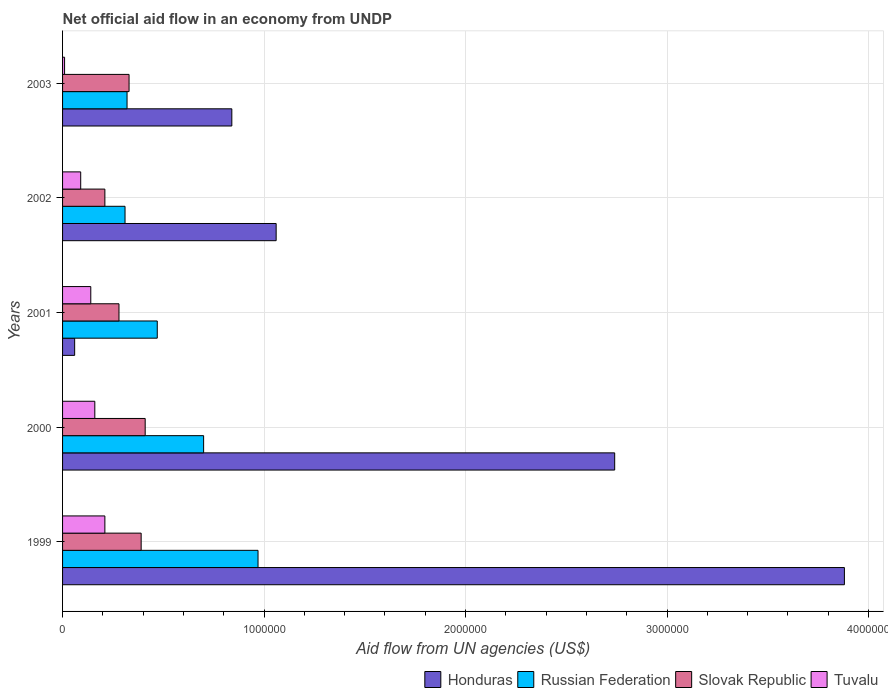How many different coloured bars are there?
Make the answer very short. 4. Are the number of bars per tick equal to the number of legend labels?
Provide a short and direct response. Yes. How many bars are there on the 5th tick from the top?
Ensure brevity in your answer.  4. What is the label of the 2nd group of bars from the top?
Your answer should be compact. 2002. In how many cases, is the number of bars for a given year not equal to the number of legend labels?
Your answer should be very brief. 0. Across all years, what is the maximum net official aid flow in Honduras?
Your answer should be very brief. 3.88e+06. Across all years, what is the minimum net official aid flow in Honduras?
Offer a very short reply. 6.00e+04. What is the total net official aid flow in Honduras in the graph?
Offer a terse response. 8.58e+06. What is the difference between the net official aid flow in Slovak Republic in 2001 and the net official aid flow in Honduras in 2002?
Your response must be concise. -7.80e+05. What is the average net official aid flow in Tuvalu per year?
Offer a terse response. 1.22e+05. In how many years, is the net official aid flow in Russian Federation greater than 2200000 US$?
Ensure brevity in your answer.  0. What is the ratio of the net official aid flow in Tuvalu in 1999 to that in 2002?
Your answer should be compact. 2.33. Is the net official aid flow in Honduras in 2002 less than that in 2003?
Your answer should be very brief. No. What does the 3rd bar from the top in 2000 represents?
Offer a terse response. Russian Federation. What does the 4th bar from the bottom in 1999 represents?
Ensure brevity in your answer.  Tuvalu. Is it the case that in every year, the sum of the net official aid flow in Russian Federation and net official aid flow in Slovak Republic is greater than the net official aid flow in Honduras?
Provide a short and direct response. No. How many bars are there?
Provide a succinct answer. 20. Are all the bars in the graph horizontal?
Provide a short and direct response. Yes. How many years are there in the graph?
Your answer should be compact. 5. Are the values on the major ticks of X-axis written in scientific E-notation?
Make the answer very short. No. Does the graph contain any zero values?
Ensure brevity in your answer.  No. Does the graph contain grids?
Your response must be concise. Yes. How are the legend labels stacked?
Keep it short and to the point. Horizontal. What is the title of the graph?
Your answer should be very brief. Net official aid flow in an economy from UNDP. Does "Portugal" appear as one of the legend labels in the graph?
Make the answer very short. No. What is the label or title of the X-axis?
Your answer should be compact. Aid flow from UN agencies (US$). What is the Aid flow from UN agencies (US$) of Honduras in 1999?
Make the answer very short. 3.88e+06. What is the Aid flow from UN agencies (US$) of Russian Federation in 1999?
Offer a very short reply. 9.70e+05. What is the Aid flow from UN agencies (US$) of Honduras in 2000?
Your response must be concise. 2.74e+06. What is the Aid flow from UN agencies (US$) of Tuvalu in 2000?
Make the answer very short. 1.60e+05. What is the Aid flow from UN agencies (US$) of Russian Federation in 2001?
Your answer should be compact. 4.70e+05. What is the Aid flow from UN agencies (US$) in Tuvalu in 2001?
Your answer should be compact. 1.40e+05. What is the Aid flow from UN agencies (US$) of Honduras in 2002?
Ensure brevity in your answer.  1.06e+06. What is the Aid flow from UN agencies (US$) of Russian Federation in 2002?
Your answer should be compact. 3.10e+05. What is the Aid flow from UN agencies (US$) of Slovak Republic in 2002?
Make the answer very short. 2.10e+05. What is the Aid flow from UN agencies (US$) of Honduras in 2003?
Your answer should be compact. 8.40e+05. What is the Aid flow from UN agencies (US$) of Tuvalu in 2003?
Offer a very short reply. 10000. Across all years, what is the maximum Aid flow from UN agencies (US$) of Honduras?
Your answer should be very brief. 3.88e+06. Across all years, what is the maximum Aid flow from UN agencies (US$) of Russian Federation?
Your answer should be compact. 9.70e+05. Across all years, what is the maximum Aid flow from UN agencies (US$) of Tuvalu?
Provide a succinct answer. 2.10e+05. Across all years, what is the minimum Aid flow from UN agencies (US$) in Honduras?
Your answer should be very brief. 6.00e+04. Across all years, what is the minimum Aid flow from UN agencies (US$) in Slovak Republic?
Give a very brief answer. 2.10e+05. Across all years, what is the minimum Aid flow from UN agencies (US$) of Tuvalu?
Make the answer very short. 10000. What is the total Aid flow from UN agencies (US$) of Honduras in the graph?
Offer a terse response. 8.58e+06. What is the total Aid flow from UN agencies (US$) of Russian Federation in the graph?
Provide a short and direct response. 2.77e+06. What is the total Aid flow from UN agencies (US$) in Slovak Republic in the graph?
Your answer should be compact. 1.62e+06. What is the difference between the Aid flow from UN agencies (US$) of Honduras in 1999 and that in 2000?
Provide a succinct answer. 1.14e+06. What is the difference between the Aid flow from UN agencies (US$) of Tuvalu in 1999 and that in 2000?
Give a very brief answer. 5.00e+04. What is the difference between the Aid flow from UN agencies (US$) of Honduras in 1999 and that in 2001?
Your answer should be compact. 3.82e+06. What is the difference between the Aid flow from UN agencies (US$) of Slovak Republic in 1999 and that in 2001?
Your answer should be compact. 1.10e+05. What is the difference between the Aid flow from UN agencies (US$) in Honduras in 1999 and that in 2002?
Provide a succinct answer. 2.82e+06. What is the difference between the Aid flow from UN agencies (US$) of Slovak Republic in 1999 and that in 2002?
Your answer should be compact. 1.80e+05. What is the difference between the Aid flow from UN agencies (US$) in Tuvalu in 1999 and that in 2002?
Provide a short and direct response. 1.20e+05. What is the difference between the Aid flow from UN agencies (US$) in Honduras in 1999 and that in 2003?
Your response must be concise. 3.04e+06. What is the difference between the Aid flow from UN agencies (US$) of Russian Federation in 1999 and that in 2003?
Your answer should be very brief. 6.50e+05. What is the difference between the Aid flow from UN agencies (US$) of Honduras in 2000 and that in 2001?
Provide a short and direct response. 2.68e+06. What is the difference between the Aid flow from UN agencies (US$) of Russian Federation in 2000 and that in 2001?
Ensure brevity in your answer.  2.30e+05. What is the difference between the Aid flow from UN agencies (US$) in Slovak Republic in 2000 and that in 2001?
Give a very brief answer. 1.30e+05. What is the difference between the Aid flow from UN agencies (US$) in Tuvalu in 2000 and that in 2001?
Ensure brevity in your answer.  2.00e+04. What is the difference between the Aid flow from UN agencies (US$) of Honduras in 2000 and that in 2002?
Keep it short and to the point. 1.68e+06. What is the difference between the Aid flow from UN agencies (US$) in Russian Federation in 2000 and that in 2002?
Offer a terse response. 3.90e+05. What is the difference between the Aid flow from UN agencies (US$) of Tuvalu in 2000 and that in 2002?
Offer a very short reply. 7.00e+04. What is the difference between the Aid flow from UN agencies (US$) of Honduras in 2000 and that in 2003?
Provide a short and direct response. 1.90e+06. What is the difference between the Aid flow from UN agencies (US$) of Slovak Republic in 2000 and that in 2003?
Your answer should be compact. 8.00e+04. What is the difference between the Aid flow from UN agencies (US$) of Honduras in 2001 and that in 2002?
Provide a short and direct response. -1.00e+06. What is the difference between the Aid flow from UN agencies (US$) in Slovak Republic in 2001 and that in 2002?
Provide a short and direct response. 7.00e+04. What is the difference between the Aid flow from UN agencies (US$) of Tuvalu in 2001 and that in 2002?
Keep it short and to the point. 5.00e+04. What is the difference between the Aid flow from UN agencies (US$) in Honduras in 2001 and that in 2003?
Your answer should be very brief. -7.80e+05. What is the difference between the Aid flow from UN agencies (US$) in Slovak Republic in 2001 and that in 2003?
Your answer should be compact. -5.00e+04. What is the difference between the Aid flow from UN agencies (US$) in Tuvalu in 2001 and that in 2003?
Give a very brief answer. 1.30e+05. What is the difference between the Aid flow from UN agencies (US$) of Honduras in 2002 and that in 2003?
Give a very brief answer. 2.20e+05. What is the difference between the Aid flow from UN agencies (US$) in Tuvalu in 2002 and that in 2003?
Your answer should be very brief. 8.00e+04. What is the difference between the Aid flow from UN agencies (US$) in Honduras in 1999 and the Aid flow from UN agencies (US$) in Russian Federation in 2000?
Make the answer very short. 3.18e+06. What is the difference between the Aid flow from UN agencies (US$) in Honduras in 1999 and the Aid flow from UN agencies (US$) in Slovak Republic in 2000?
Keep it short and to the point. 3.47e+06. What is the difference between the Aid flow from UN agencies (US$) in Honduras in 1999 and the Aid flow from UN agencies (US$) in Tuvalu in 2000?
Your answer should be compact. 3.72e+06. What is the difference between the Aid flow from UN agencies (US$) in Russian Federation in 1999 and the Aid flow from UN agencies (US$) in Slovak Republic in 2000?
Make the answer very short. 5.60e+05. What is the difference between the Aid flow from UN agencies (US$) in Russian Federation in 1999 and the Aid flow from UN agencies (US$) in Tuvalu in 2000?
Your answer should be very brief. 8.10e+05. What is the difference between the Aid flow from UN agencies (US$) in Slovak Republic in 1999 and the Aid flow from UN agencies (US$) in Tuvalu in 2000?
Provide a short and direct response. 2.30e+05. What is the difference between the Aid flow from UN agencies (US$) of Honduras in 1999 and the Aid flow from UN agencies (US$) of Russian Federation in 2001?
Give a very brief answer. 3.41e+06. What is the difference between the Aid flow from UN agencies (US$) of Honduras in 1999 and the Aid flow from UN agencies (US$) of Slovak Republic in 2001?
Keep it short and to the point. 3.60e+06. What is the difference between the Aid flow from UN agencies (US$) in Honduras in 1999 and the Aid flow from UN agencies (US$) in Tuvalu in 2001?
Your response must be concise. 3.74e+06. What is the difference between the Aid flow from UN agencies (US$) of Russian Federation in 1999 and the Aid flow from UN agencies (US$) of Slovak Republic in 2001?
Give a very brief answer. 6.90e+05. What is the difference between the Aid flow from UN agencies (US$) in Russian Federation in 1999 and the Aid flow from UN agencies (US$) in Tuvalu in 2001?
Offer a very short reply. 8.30e+05. What is the difference between the Aid flow from UN agencies (US$) in Honduras in 1999 and the Aid flow from UN agencies (US$) in Russian Federation in 2002?
Provide a short and direct response. 3.57e+06. What is the difference between the Aid flow from UN agencies (US$) in Honduras in 1999 and the Aid flow from UN agencies (US$) in Slovak Republic in 2002?
Provide a short and direct response. 3.67e+06. What is the difference between the Aid flow from UN agencies (US$) of Honduras in 1999 and the Aid flow from UN agencies (US$) of Tuvalu in 2002?
Provide a succinct answer. 3.79e+06. What is the difference between the Aid flow from UN agencies (US$) of Russian Federation in 1999 and the Aid flow from UN agencies (US$) of Slovak Republic in 2002?
Keep it short and to the point. 7.60e+05. What is the difference between the Aid flow from UN agencies (US$) of Russian Federation in 1999 and the Aid flow from UN agencies (US$) of Tuvalu in 2002?
Make the answer very short. 8.80e+05. What is the difference between the Aid flow from UN agencies (US$) in Slovak Republic in 1999 and the Aid flow from UN agencies (US$) in Tuvalu in 2002?
Your answer should be compact. 3.00e+05. What is the difference between the Aid flow from UN agencies (US$) in Honduras in 1999 and the Aid flow from UN agencies (US$) in Russian Federation in 2003?
Your answer should be compact. 3.56e+06. What is the difference between the Aid flow from UN agencies (US$) in Honduras in 1999 and the Aid flow from UN agencies (US$) in Slovak Republic in 2003?
Offer a very short reply. 3.55e+06. What is the difference between the Aid flow from UN agencies (US$) in Honduras in 1999 and the Aid flow from UN agencies (US$) in Tuvalu in 2003?
Offer a terse response. 3.87e+06. What is the difference between the Aid flow from UN agencies (US$) of Russian Federation in 1999 and the Aid flow from UN agencies (US$) of Slovak Republic in 2003?
Your answer should be very brief. 6.40e+05. What is the difference between the Aid flow from UN agencies (US$) in Russian Federation in 1999 and the Aid flow from UN agencies (US$) in Tuvalu in 2003?
Make the answer very short. 9.60e+05. What is the difference between the Aid flow from UN agencies (US$) in Slovak Republic in 1999 and the Aid flow from UN agencies (US$) in Tuvalu in 2003?
Your answer should be compact. 3.80e+05. What is the difference between the Aid flow from UN agencies (US$) of Honduras in 2000 and the Aid flow from UN agencies (US$) of Russian Federation in 2001?
Keep it short and to the point. 2.27e+06. What is the difference between the Aid flow from UN agencies (US$) in Honduras in 2000 and the Aid flow from UN agencies (US$) in Slovak Republic in 2001?
Ensure brevity in your answer.  2.46e+06. What is the difference between the Aid flow from UN agencies (US$) of Honduras in 2000 and the Aid flow from UN agencies (US$) of Tuvalu in 2001?
Your response must be concise. 2.60e+06. What is the difference between the Aid flow from UN agencies (US$) of Russian Federation in 2000 and the Aid flow from UN agencies (US$) of Slovak Republic in 2001?
Offer a terse response. 4.20e+05. What is the difference between the Aid flow from UN agencies (US$) in Russian Federation in 2000 and the Aid flow from UN agencies (US$) in Tuvalu in 2001?
Provide a succinct answer. 5.60e+05. What is the difference between the Aid flow from UN agencies (US$) in Slovak Republic in 2000 and the Aid flow from UN agencies (US$) in Tuvalu in 2001?
Provide a short and direct response. 2.70e+05. What is the difference between the Aid flow from UN agencies (US$) of Honduras in 2000 and the Aid flow from UN agencies (US$) of Russian Federation in 2002?
Make the answer very short. 2.43e+06. What is the difference between the Aid flow from UN agencies (US$) of Honduras in 2000 and the Aid flow from UN agencies (US$) of Slovak Republic in 2002?
Offer a terse response. 2.53e+06. What is the difference between the Aid flow from UN agencies (US$) in Honduras in 2000 and the Aid flow from UN agencies (US$) in Tuvalu in 2002?
Offer a terse response. 2.65e+06. What is the difference between the Aid flow from UN agencies (US$) of Russian Federation in 2000 and the Aid flow from UN agencies (US$) of Tuvalu in 2002?
Keep it short and to the point. 6.10e+05. What is the difference between the Aid flow from UN agencies (US$) in Slovak Republic in 2000 and the Aid flow from UN agencies (US$) in Tuvalu in 2002?
Keep it short and to the point. 3.20e+05. What is the difference between the Aid flow from UN agencies (US$) in Honduras in 2000 and the Aid flow from UN agencies (US$) in Russian Federation in 2003?
Your answer should be very brief. 2.42e+06. What is the difference between the Aid flow from UN agencies (US$) in Honduras in 2000 and the Aid flow from UN agencies (US$) in Slovak Republic in 2003?
Your answer should be compact. 2.41e+06. What is the difference between the Aid flow from UN agencies (US$) of Honduras in 2000 and the Aid flow from UN agencies (US$) of Tuvalu in 2003?
Your response must be concise. 2.73e+06. What is the difference between the Aid flow from UN agencies (US$) in Russian Federation in 2000 and the Aid flow from UN agencies (US$) in Tuvalu in 2003?
Offer a terse response. 6.90e+05. What is the difference between the Aid flow from UN agencies (US$) in Slovak Republic in 2000 and the Aid flow from UN agencies (US$) in Tuvalu in 2003?
Your answer should be very brief. 4.00e+05. What is the difference between the Aid flow from UN agencies (US$) in Honduras in 2001 and the Aid flow from UN agencies (US$) in Slovak Republic in 2002?
Give a very brief answer. -1.50e+05. What is the difference between the Aid flow from UN agencies (US$) of Honduras in 2001 and the Aid flow from UN agencies (US$) of Tuvalu in 2002?
Keep it short and to the point. -3.00e+04. What is the difference between the Aid flow from UN agencies (US$) in Russian Federation in 2001 and the Aid flow from UN agencies (US$) in Slovak Republic in 2002?
Offer a very short reply. 2.60e+05. What is the difference between the Aid flow from UN agencies (US$) of Slovak Republic in 2001 and the Aid flow from UN agencies (US$) of Tuvalu in 2002?
Provide a short and direct response. 1.90e+05. What is the difference between the Aid flow from UN agencies (US$) in Honduras in 2001 and the Aid flow from UN agencies (US$) in Tuvalu in 2003?
Ensure brevity in your answer.  5.00e+04. What is the difference between the Aid flow from UN agencies (US$) of Honduras in 2002 and the Aid flow from UN agencies (US$) of Russian Federation in 2003?
Offer a terse response. 7.40e+05. What is the difference between the Aid flow from UN agencies (US$) of Honduras in 2002 and the Aid flow from UN agencies (US$) of Slovak Republic in 2003?
Provide a succinct answer. 7.30e+05. What is the difference between the Aid flow from UN agencies (US$) of Honduras in 2002 and the Aid flow from UN agencies (US$) of Tuvalu in 2003?
Keep it short and to the point. 1.05e+06. What is the difference between the Aid flow from UN agencies (US$) in Russian Federation in 2002 and the Aid flow from UN agencies (US$) in Slovak Republic in 2003?
Your answer should be compact. -2.00e+04. What is the difference between the Aid flow from UN agencies (US$) in Russian Federation in 2002 and the Aid flow from UN agencies (US$) in Tuvalu in 2003?
Provide a short and direct response. 3.00e+05. What is the average Aid flow from UN agencies (US$) in Honduras per year?
Provide a short and direct response. 1.72e+06. What is the average Aid flow from UN agencies (US$) of Russian Federation per year?
Provide a short and direct response. 5.54e+05. What is the average Aid flow from UN agencies (US$) in Slovak Republic per year?
Your answer should be very brief. 3.24e+05. What is the average Aid flow from UN agencies (US$) of Tuvalu per year?
Your answer should be compact. 1.22e+05. In the year 1999, what is the difference between the Aid flow from UN agencies (US$) in Honduras and Aid flow from UN agencies (US$) in Russian Federation?
Provide a short and direct response. 2.91e+06. In the year 1999, what is the difference between the Aid flow from UN agencies (US$) in Honduras and Aid flow from UN agencies (US$) in Slovak Republic?
Provide a short and direct response. 3.49e+06. In the year 1999, what is the difference between the Aid flow from UN agencies (US$) of Honduras and Aid flow from UN agencies (US$) of Tuvalu?
Your answer should be compact. 3.67e+06. In the year 1999, what is the difference between the Aid flow from UN agencies (US$) of Russian Federation and Aid flow from UN agencies (US$) of Slovak Republic?
Ensure brevity in your answer.  5.80e+05. In the year 1999, what is the difference between the Aid flow from UN agencies (US$) of Russian Federation and Aid flow from UN agencies (US$) of Tuvalu?
Provide a short and direct response. 7.60e+05. In the year 2000, what is the difference between the Aid flow from UN agencies (US$) of Honduras and Aid flow from UN agencies (US$) of Russian Federation?
Keep it short and to the point. 2.04e+06. In the year 2000, what is the difference between the Aid flow from UN agencies (US$) of Honduras and Aid flow from UN agencies (US$) of Slovak Republic?
Offer a very short reply. 2.33e+06. In the year 2000, what is the difference between the Aid flow from UN agencies (US$) in Honduras and Aid flow from UN agencies (US$) in Tuvalu?
Keep it short and to the point. 2.58e+06. In the year 2000, what is the difference between the Aid flow from UN agencies (US$) of Russian Federation and Aid flow from UN agencies (US$) of Slovak Republic?
Provide a succinct answer. 2.90e+05. In the year 2000, what is the difference between the Aid flow from UN agencies (US$) of Russian Federation and Aid flow from UN agencies (US$) of Tuvalu?
Give a very brief answer. 5.40e+05. In the year 2001, what is the difference between the Aid flow from UN agencies (US$) in Honduras and Aid flow from UN agencies (US$) in Russian Federation?
Ensure brevity in your answer.  -4.10e+05. In the year 2002, what is the difference between the Aid flow from UN agencies (US$) of Honduras and Aid flow from UN agencies (US$) of Russian Federation?
Your answer should be very brief. 7.50e+05. In the year 2002, what is the difference between the Aid flow from UN agencies (US$) in Honduras and Aid flow from UN agencies (US$) in Slovak Republic?
Offer a terse response. 8.50e+05. In the year 2002, what is the difference between the Aid flow from UN agencies (US$) of Honduras and Aid flow from UN agencies (US$) of Tuvalu?
Your response must be concise. 9.70e+05. In the year 2002, what is the difference between the Aid flow from UN agencies (US$) of Russian Federation and Aid flow from UN agencies (US$) of Slovak Republic?
Provide a short and direct response. 1.00e+05. In the year 2002, what is the difference between the Aid flow from UN agencies (US$) of Russian Federation and Aid flow from UN agencies (US$) of Tuvalu?
Offer a very short reply. 2.20e+05. In the year 2003, what is the difference between the Aid flow from UN agencies (US$) in Honduras and Aid flow from UN agencies (US$) in Russian Federation?
Provide a succinct answer. 5.20e+05. In the year 2003, what is the difference between the Aid flow from UN agencies (US$) of Honduras and Aid flow from UN agencies (US$) of Slovak Republic?
Offer a very short reply. 5.10e+05. In the year 2003, what is the difference between the Aid flow from UN agencies (US$) of Honduras and Aid flow from UN agencies (US$) of Tuvalu?
Keep it short and to the point. 8.30e+05. In the year 2003, what is the difference between the Aid flow from UN agencies (US$) of Slovak Republic and Aid flow from UN agencies (US$) of Tuvalu?
Provide a succinct answer. 3.20e+05. What is the ratio of the Aid flow from UN agencies (US$) of Honduras in 1999 to that in 2000?
Provide a short and direct response. 1.42. What is the ratio of the Aid flow from UN agencies (US$) in Russian Federation in 1999 to that in 2000?
Ensure brevity in your answer.  1.39. What is the ratio of the Aid flow from UN agencies (US$) of Slovak Republic in 1999 to that in 2000?
Provide a short and direct response. 0.95. What is the ratio of the Aid flow from UN agencies (US$) of Tuvalu in 1999 to that in 2000?
Your response must be concise. 1.31. What is the ratio of the Aid flow from UN agencies (US$) in Honduras in 1999 to that in 2001?
Keep it short and to the point. 64.67. What is the ratio of the Aid flow from UN agencies (US$) of Russian Federation in 1999 to that in 2001?
Provide a short and direct response. 2.06. What is the ratio of the Aid flow from UN agencies (US$) of Slovak Republic in 1999 to that in 2001?
Provide a short and direct response. 1.39. What is the ratio of the Aid flow from UN agencies (US$) in Honduras in 1999 to that in 2002?
Your response must be concise. 3.66. What is the ratio of the Aid flow from UN agencies (US$) of Russian Federation in 1999 to that in 2002?
Provide a succinct answer. 3.13. What is the ratio of the Aid flow from UN agencies (US$) in Slovak Republic in 1999 to that in 2002?
Give a very brief answer. 1.86. What is the ratio of the Aid flow from UN agencies (US$) of Tuvalu in 1999 to that in 2002?
Provide a short and direct response. 2.33. What is the ratio of the Aid flow from UN agencies (US$) of Honduras in 1999 to that in 2003?
Give a very brief answer. 4.62. What is the ratio of the Aid flow from UN agencies (US$) in Russian Federation in 1999 to that in 2003?
Make the answer very short. 3.03. What is the ratio of the Aid flow from UN agencies (US$) of Slovak Republic in 1999 to that in 2003?
Provide a short and direct response. 1.18. What is the ratio of the Aid flow from UN agencies (US$) of Honduras in 2000 to that in 2001?
Offer a very short reply. 45.67. What is the ratio of the Aid flow from UN agencies (US$) of Russian Federation in 2000 to that in 2001?
Offer a terse response. 1.49. What is the ratio of the Aid flow from UN agencies (US$) of Slovak Republic in 2000 to that in 2001?
Offer a terse response. 1.46. What is the ratio of the Aid flow from UN agencies (US$) of Tuvalu in 2000 to that in 2001?
Your response must be concise. 1.14. What is the ratio of the Aid flow from UN agencies (US$) in Honduras in 2000 to that in 2002?
Make the answer very short. 2.58. What is the ratio of the Aid flow from UN agencies (US$) in Russian Federation in 2000 to that in 2002?
Ensure brevity in your answer.  2.26. What is the ratio of the Aid flow from UN agencies (US$) of Slovak Republic in 2000 to that in 2002?
Ensure brevity in your answer.  1.95. What is the ratio of the Aid flow from UN agencies (US$) of Tuvalu in 2000 to that in 2002?
Provide a succinct answer. 1.78. What is the ratio of the Aid flow from UN agencies (US$) in Honduras in 2000 to that in 2003?
Your answer should be compact. 3.26. What is the ratio of the Aid flow from UN agencies (US$) in Russian Federation in 2000 to that in 2003?
Make the answer very short. 2.19. What is the ratio of the Aid flow from UN agencies (US$) of Slovak Republic in 2000 to that in 2003?
Your answer should be compact. 1.24. What is the ratio of the Aid flow from UN agencies (US$) in Tuvalu in 2000 to that in 2003?
Keep it short and to the point. 16. What is the ratio of the Aid flow from UN agencies (US$) in Honduras in 2001 to that in 2002?
Your response must be concise. 0.06. What is the ratio of the Aid flow from UN agencies (US$) in Russian Federation in 2001 to that in 2002?
Ensure brevity in your answer.  1.52. What is the ratio of the Aid flow from UN agencies (US$) of Slovak Republic in 2001 to that in 2002?
Offer a very short reply. 1.33. What is the ratio of the Aid flow from UN agencies (US$) of Tuvalu in 2001 to that in 2002?
Offer a terse response. 1.56. What is the ratio of the Aid flow from UN agencies (US$) in Honduras in 2001 to that in 2003?
Your answer should be compact. 0.07. What is the ratio of the Aid flow from UN agencies (US$) in Russian Federation in 2001 to that in 2003?
Make the answer very short. 1.47. What is the ratio of the Aid flow from UN agencies (US$) in Slovak Republic in 2001 to that in 2003?
Keep it short and to the point. 0.85. What is the ratio of the Aid flow from UN agencies (US$) in Honduras in 2002 to that in 2003?
Your answer should be compact. 1.26. What is the ratio of the Aid flow from UN agencies (US$) of Russian Federation in 2002 to that in 2003?
Your response must be concise. 0.97. What is the ratio of the Aid flow from UN agencies (US$) of Slovak Republic in 2002 to that in 2003?
Make the answer very short. 0.64. What is the ratio of the Aid flow from UN agencies (US$) in Tuvalu in 2002 to that in 2003?
Make the answer very short. 9. What is the difference between the highest and the second highest Aid flow from UN agencies (US$) in Honduras?
Offer a very short reply. 1.14e+06. What is the difference between the highest and the second highest Aid flow from UN agencies (US$) in Slovak Republic?
Provide a succinct answer. 2.00e+04. What is the difference between the highest and the second highest Aid flow from UN agencies (US$) in Tuvalu?
Give a very brief answer. 5.00e+04. What is the difference between the highest and the lowest Aid flow from UN agencies (US$) in Honduras?
Your response must be concise. 3.82e+06. 